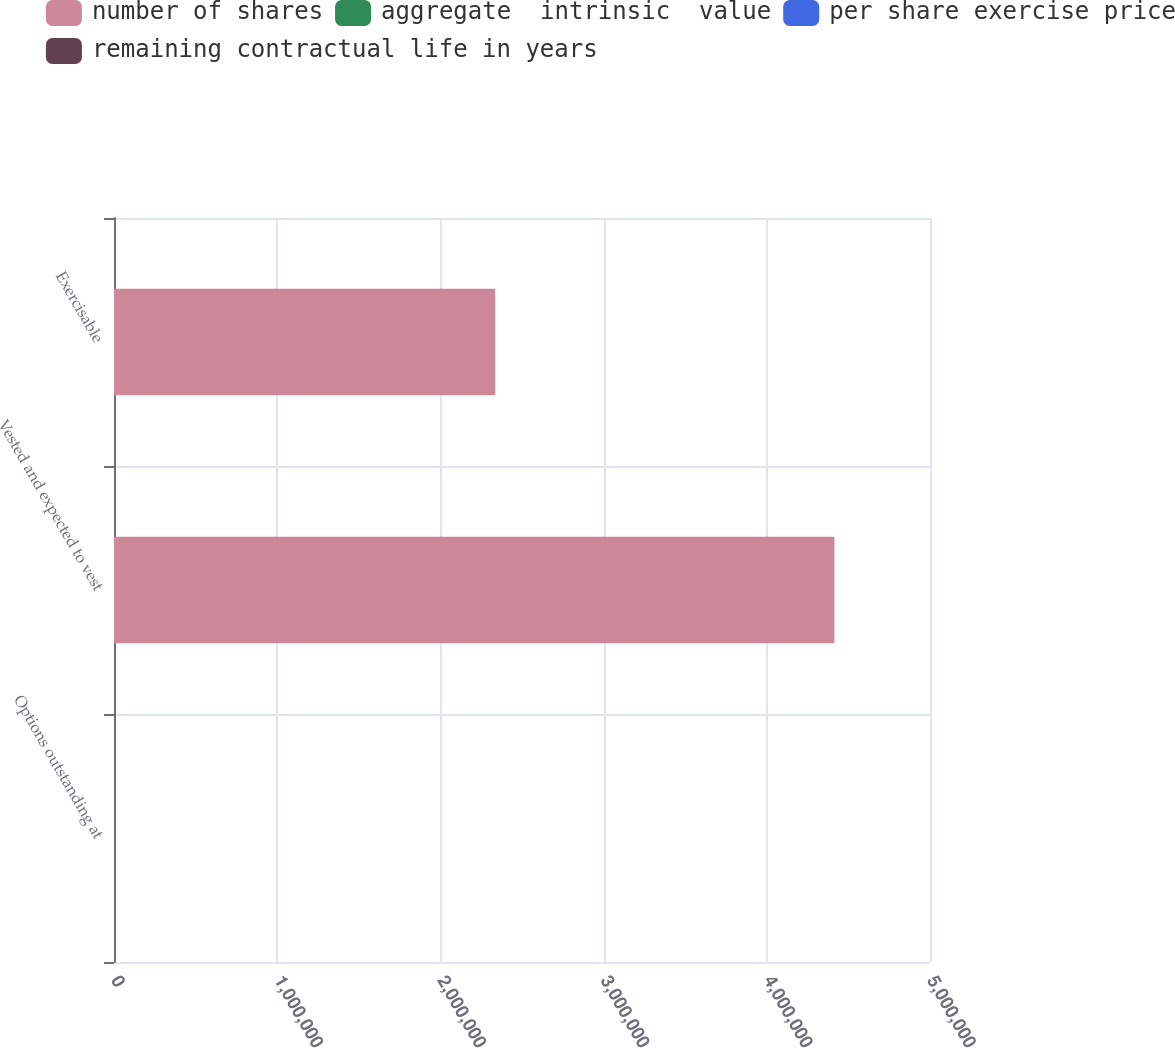Convert chart. <chart><loc_0><loc_0><loc_500><loc_500><stacked_bar_chart><ecel><fcel>Options outstanding at<fcel>Vested and expected to vest<fcel>Exercisable<nl><fcel>number of shares<fcel>44.25<fcel>4.4143e+06<fcel>2.3358e+06<nl><fcel>aggregate  intrinsic  value<fcel>44.25<fcel>43.95<fcel>39.42<nl><fcel>per share exercise price<fcel>5.9<fcel>5.82<fcel>3.9<nl><fcel>remaining contractual life in years<fcel>107.8<fcel>106.2<fcel>66.8<nl></chart> 